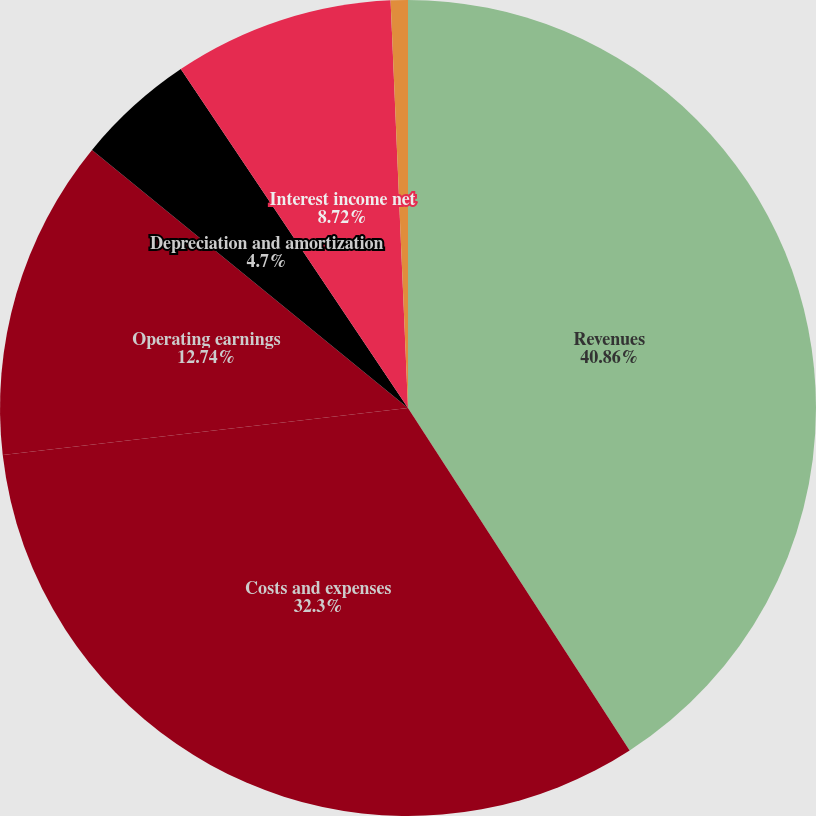<chart> <loc_0><loc_0><loc_500><loc_500><pie_chart><fcel>Revenues<fcel>Costs and expenses<fcel>Operating earnings<fcel>Depreciation and amortization<fcel>Interest income net<fcel>Additions to operating<nl><fcel>40.86%<fcel>32.3%<fcel>12.74%<fcel>4.7%<fcel>8.72%<fcel>0.68%<nl></chart> 